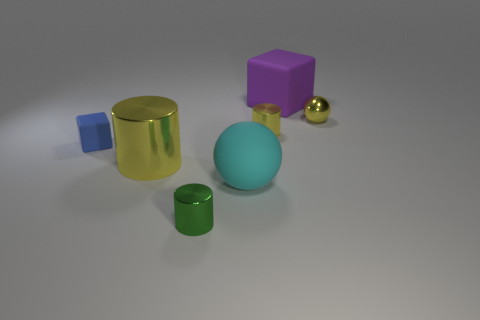Add 1 yellow metal balls. How many objects exist? 8 Subtract all large yellow cylinders. How many cylinders are left? 2 Subtract all cyan blocks. How many yellow cylinders are left? 2 Subtract 1 balls. How many balls are left? 1 Subtract all cyan balls. How many balls are left? 1 Subtract all balls. How many objects are left? 5 Subtract all yellow spheres. Subtract all brown blocks. How many spheres are left? 1 Subtract all rubber things. Subtract all small shiny objects. How many objects are left? 1 Add 1 large cyan rubber objects. How many large cyan rubber objects are left? 2 Add 5 blue cubes. How many blue cubes exist? 6 